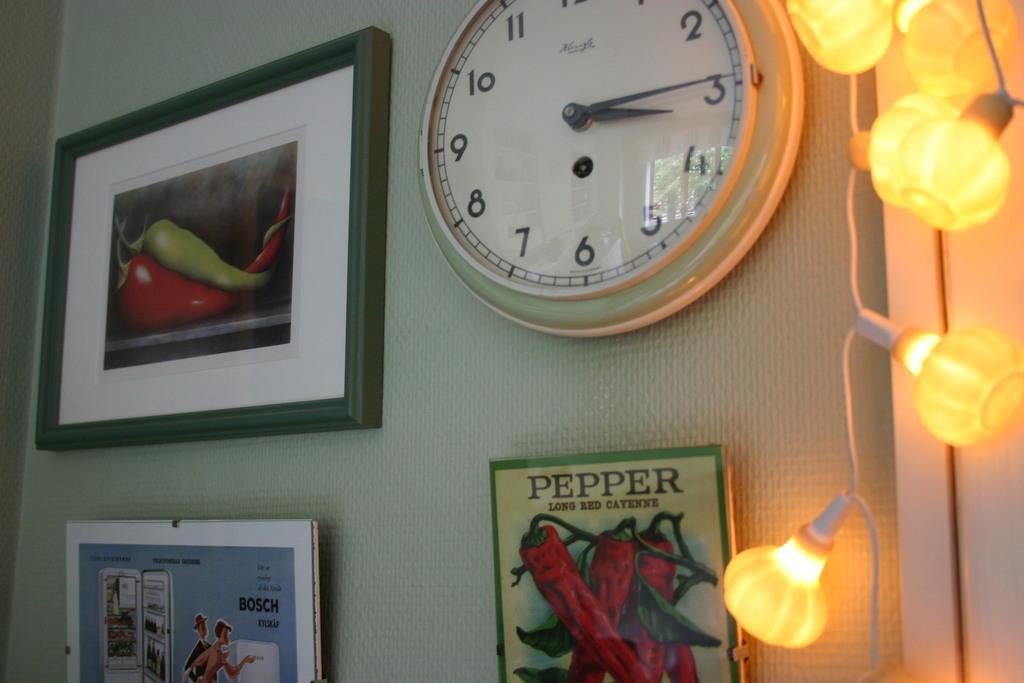Provide a one-sentence caption for the provided image. A clock is on a wall by some framed art that says Pepper Long Red Cayenne. 